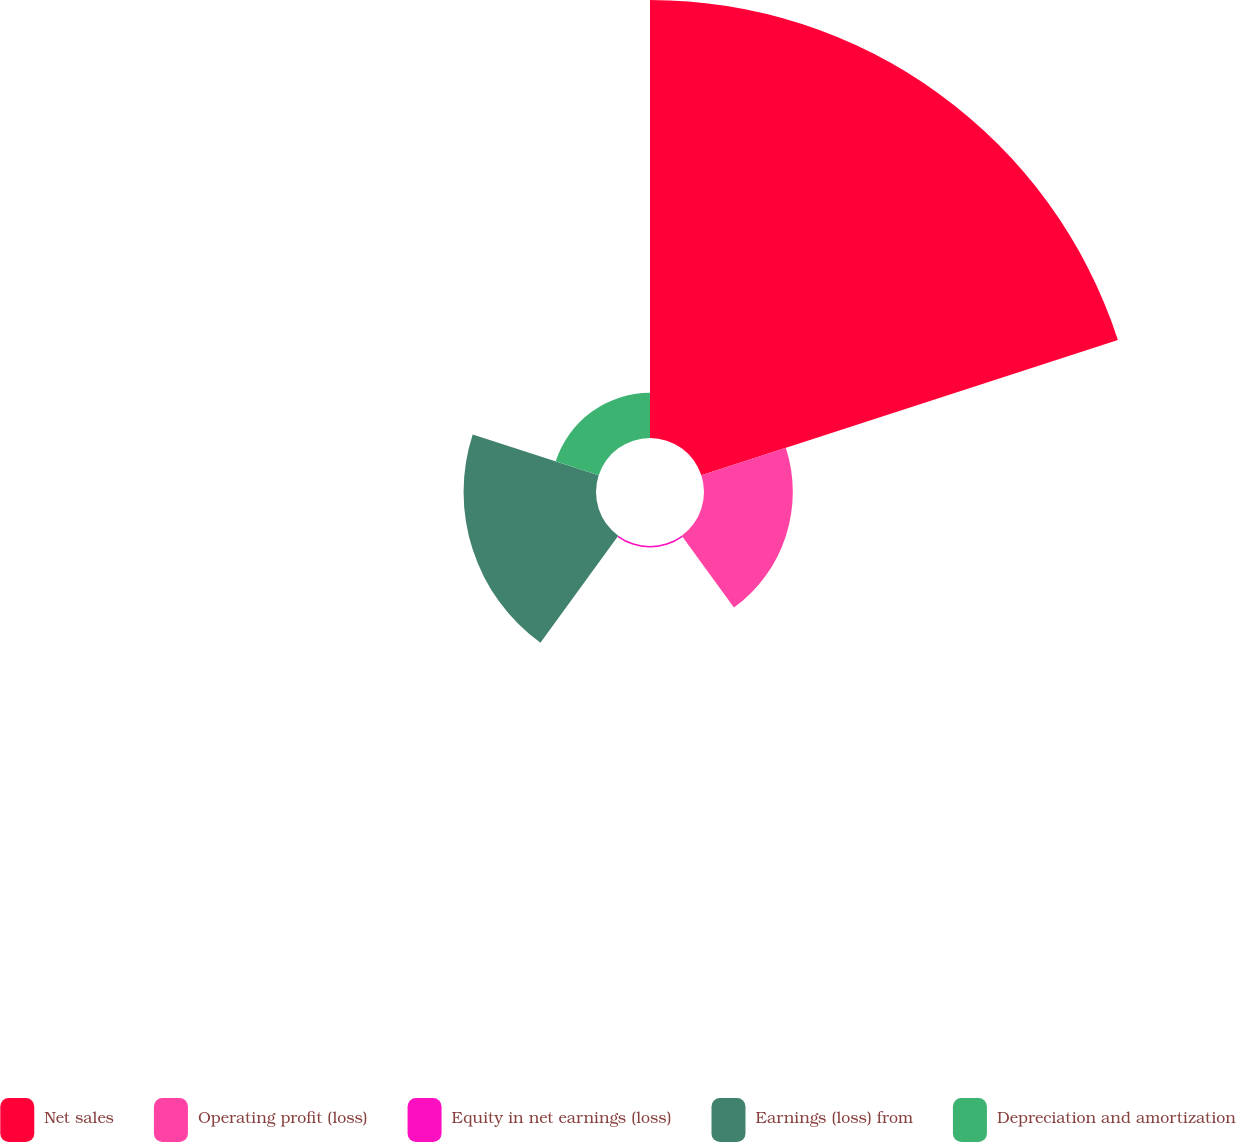Convert chart. <chart><loc_0><loc_0><loc_500><loc_500><pie_chart><fcel>Net sales<fcel>Operating profit (loss)<fcel>Equity in net earnings (loss)<fcel>Earnings (loss) from<fcel>Depreciation and amortization<nl><fcel>62.05%<fcel>12.58%<fcel>0.21%<fcel>18.76%<fcel>6.4%<nl></chart> 